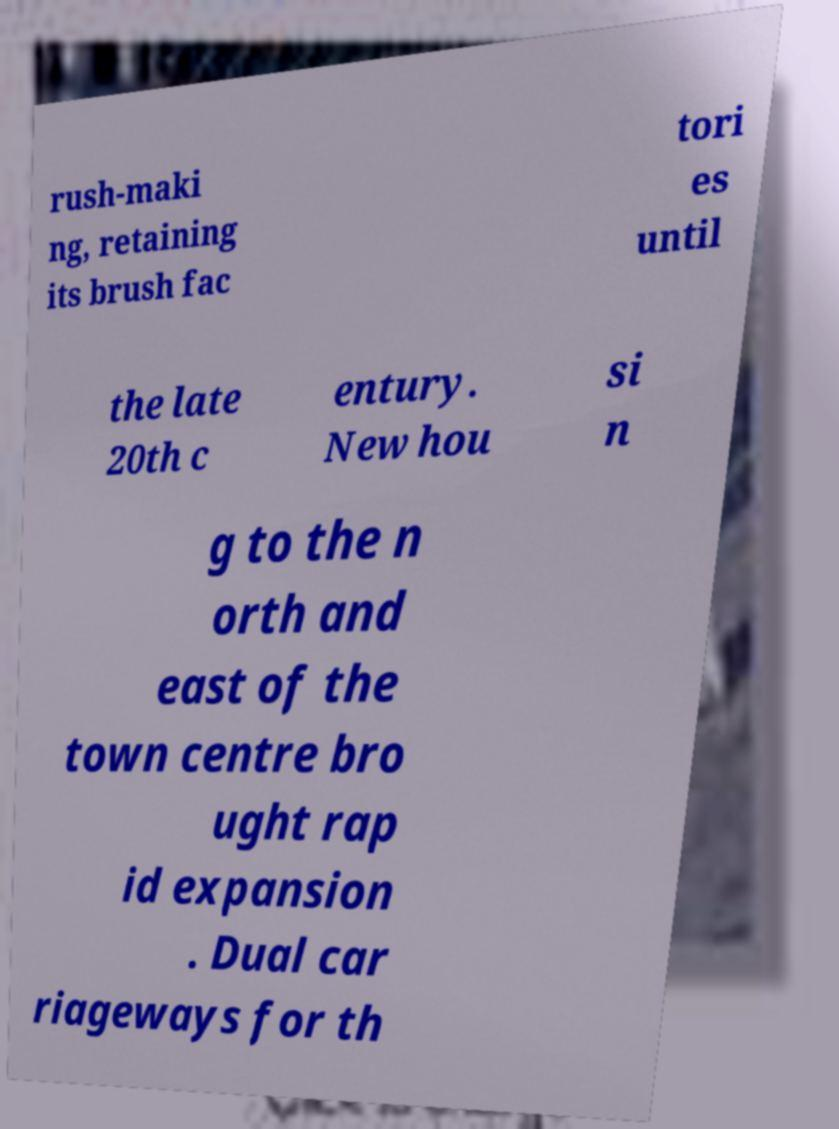Could you extract and type out the text from this image? rush-maki ng, retaining its brush fac tori es until the late 20th c entury. New hou si n g to the n orth and east of the town centre bro ught rap id expansion . Dual car riageways for th 